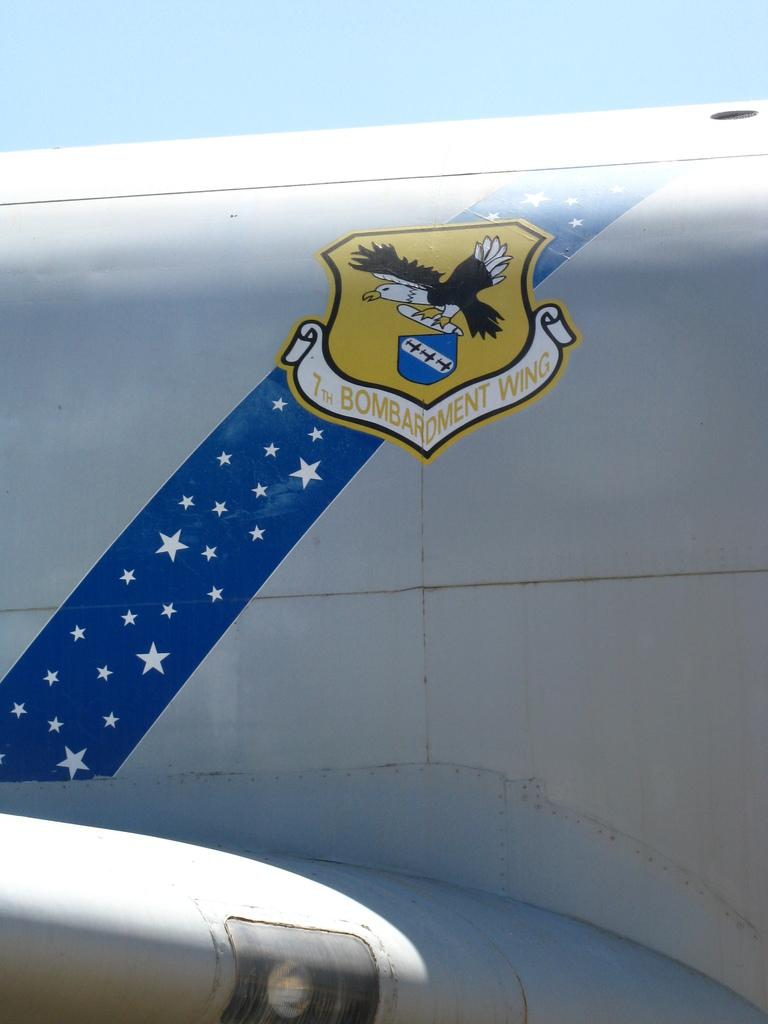<image>
Share a concise interpretation of the image provided. the side of a plane with a decal that says '7th bombardment wing' on it 